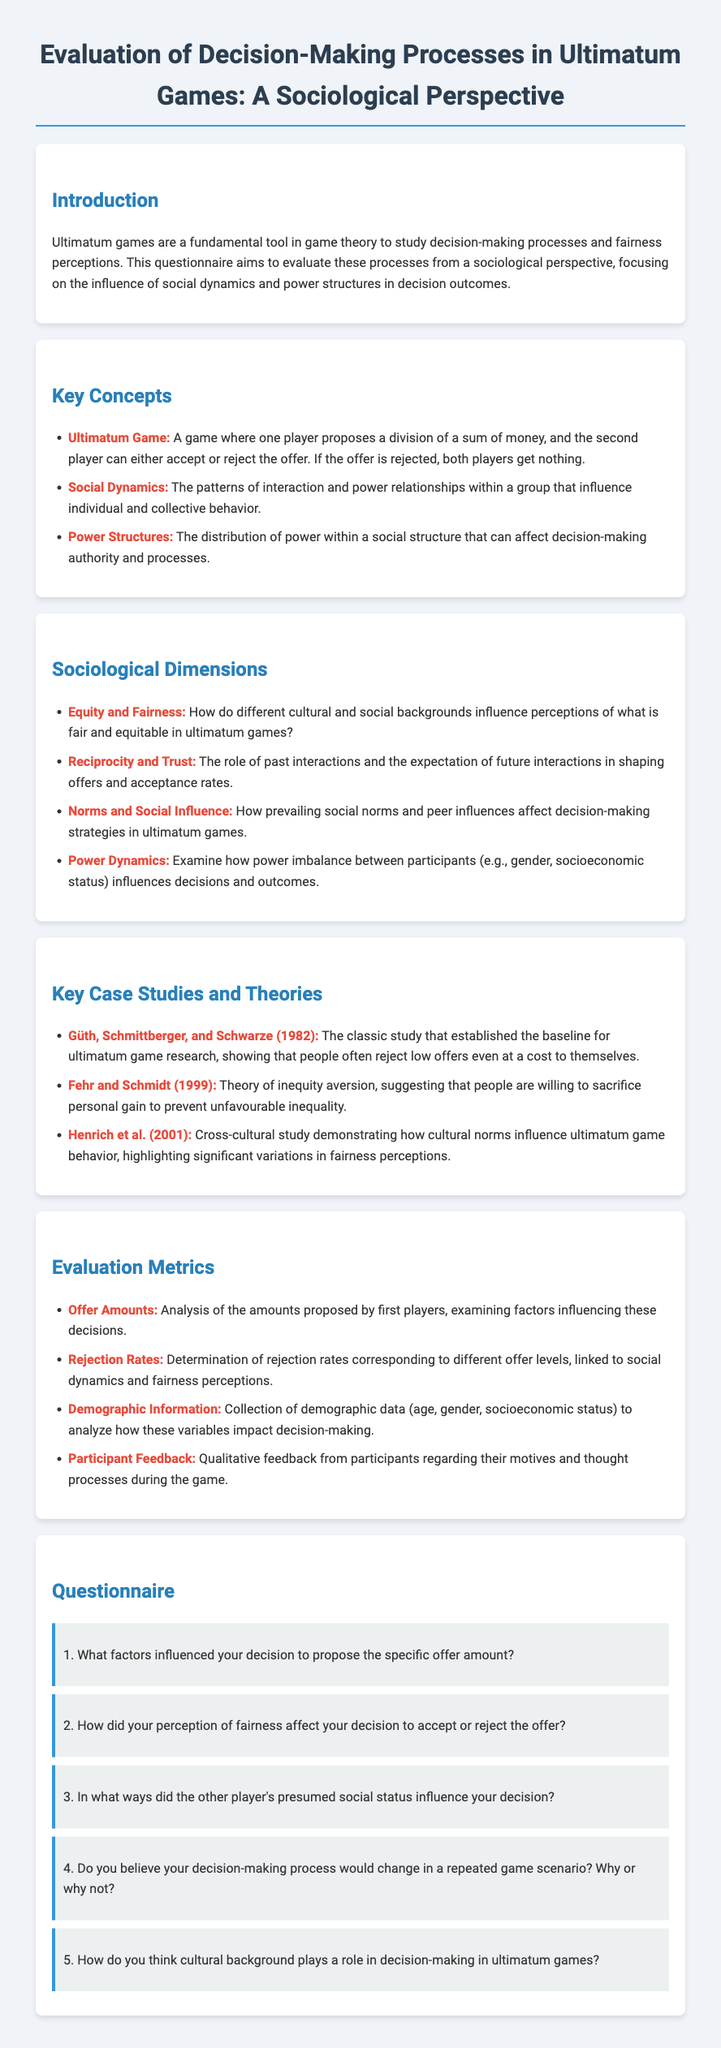What is the title of the document? The title of the document is stated in the header section of the HTML.
Answer: Evaluation of Decision-Making Processes in Ultimatum Games: A Sociological Perspective Who are the authors of the classic study mentioned? The classic study cited in the document is attributed to Güth, Schmittberger, and Schwarze.
Answer: Güth, Schmittberger, and Schwarze What is the key theory proposed by Fehr and Schmidt? The document specifies that Fehr and Schmidt proposed a theory related to inequity aversion.
Answer: Theory of inequity aversion Which sociological dimension examines interactions and future expectations? The document indicates that the sociological dimension focusing on interactions and future expectations is reciprocity and trust.
Answer: Reciprocity and Trust How many questions are included in the questionnaire section? By counting the questions listed in the questionnaire section, we find a total of five questions.
Answer: 5 What is one metric used to evaluate decision-making in ultimatum games? One evaluation metric mentioned in the document is offer amounts.
Answer: Offer Amounts What color is used for the background of the body in the document? The background color for the body in the CSS is specified as light blue.
Answer: #f0f4f8 Which player proposes a division of money in an ultimatum game? The document describes that the first player proposes a division of the sum of money.
Answer: First player 